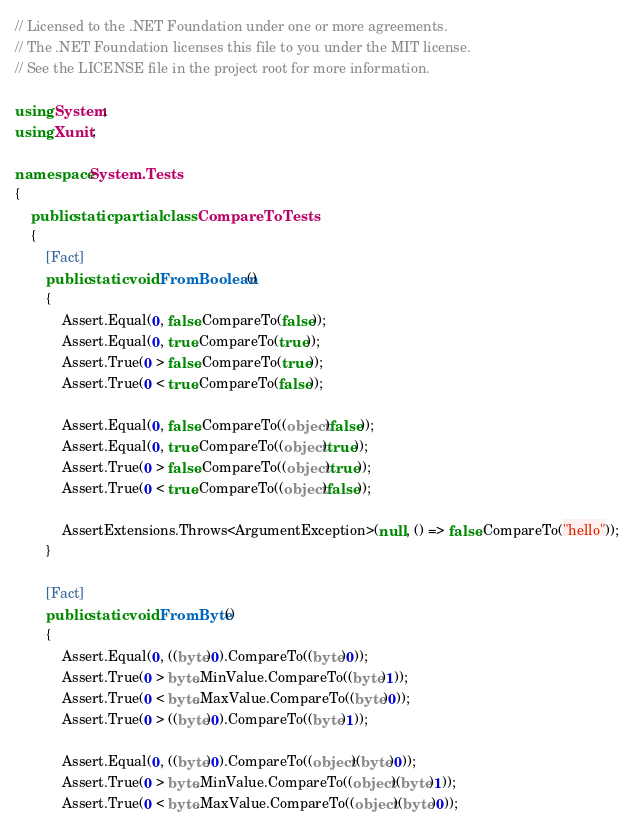<code> <loc_0><loc_0><loc_500><loc_500><_C#_>// Licensed to the .NET Foundation under one or more agreements.
// The .NET Foundation licenses this file to you under the MIT license.
// See the LICENSE file in the project root for more information.

using System;
using Xunit;

namespace System.Tests
{
    public static partial class CompareToTests
    {
        [Fact]
        public static void FromBoolean()
        {
            Assert.Equal(0, false.CompareTo(false));
            Assert.Equal(0, true.CompareTo(true));
            Assert.True(0 > false.CompareTo(true));
            Assert.True(0 < true.CompareTo(false));

            Assert.Equal(0, false.CompareTo((object)false));
            Assert.Equal(0, true.CompareTo((object)true));
            Assert.True(0 > false.CompareTo((object)true));
            Assert.True(0 < true.CompareTo((object)false));

            AssertExtensions.Throws<ArgumentException>(null, () => false.CompareTo("hello"));
        }

        [Fact]
        public static void FromByte()
        {
            Assert.Equal(0, ((byte)0).CompareTo((byte)0));
            Assert.True(0 > byte.MinValue.CompareTo((byte)1));
            Assert.True(0 < byte.MaxValue.CompareTo((byte)0));
            Assert.True(0 > ((byte)0).CompareTo((byte)1));

            Assert.Equal(0, ((byte)0).CompareTo((object)(byte)0));
            Assert.True(0 > byte.MinValue.CompareTo((object)(byte)1));
            Assert.True(0 < byte.MaxValue.CompareTo((object)(byte)0));</code> 